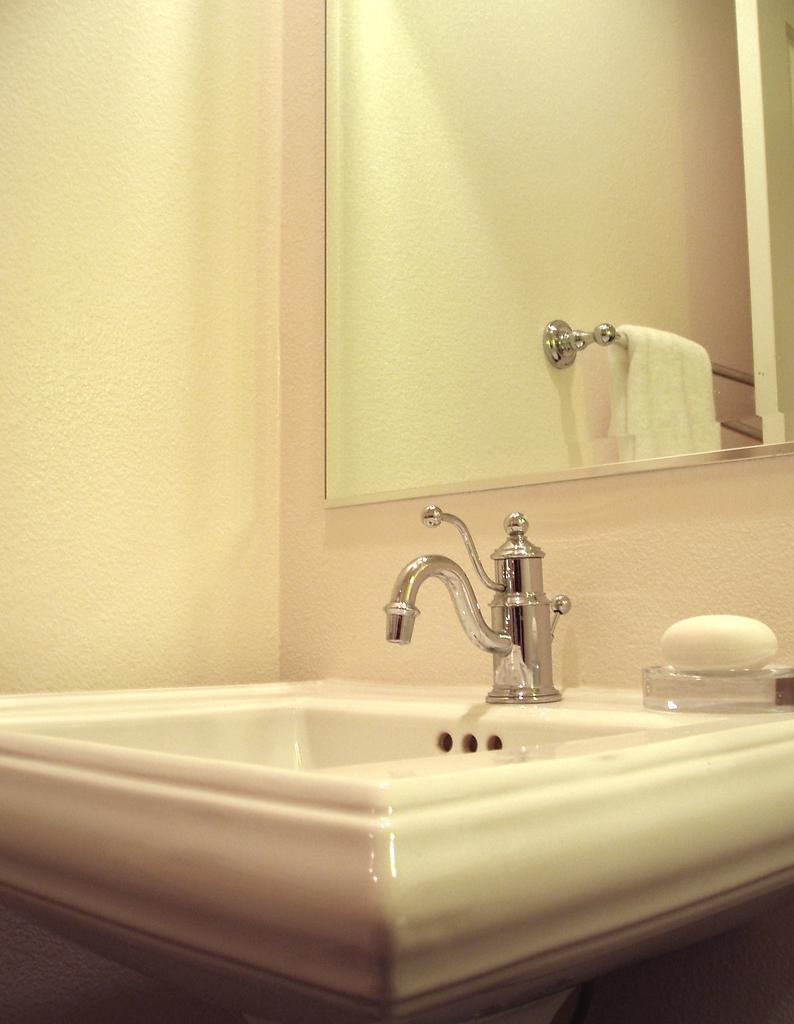Please provide a concise description of this image. This picture is taken in the room. In this image, we can see a wash basin, on the wash basin, we can see a water tap and a soap which is placed on the glass box. In the background, we can see a mirror, in the mirror, we can see a metal rod and a towel. In the background, we can also see a wall. 